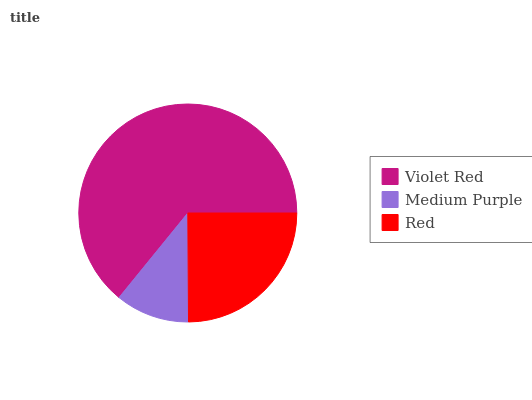Is Medium Purple the minimum?
Answer yes or no. Yes. Is Violet Red the maximum?
Answer yes or no. Yes. Is Red the minimum?
Answer yes or no. No. Is Red the maximum?
Answer yes or no. No. Is Red greater than Medium Purple?
Answer yes or no. Yes. Is Medium Purple less than Red?
Answer yes or no. Yes. Is Medium Purple greater than Red?
Answer yes or no. No. Is Red less than Medium Purple?
Answer yes or no. No. Is Red the high median?
Answer yes or no. Yes. Is Red the low median?
Answer yes or no. Yes. Is Violet Red the high median?
Answer yes or no. No. Is Medium Purple the low median?
Answer yes or no. No. 